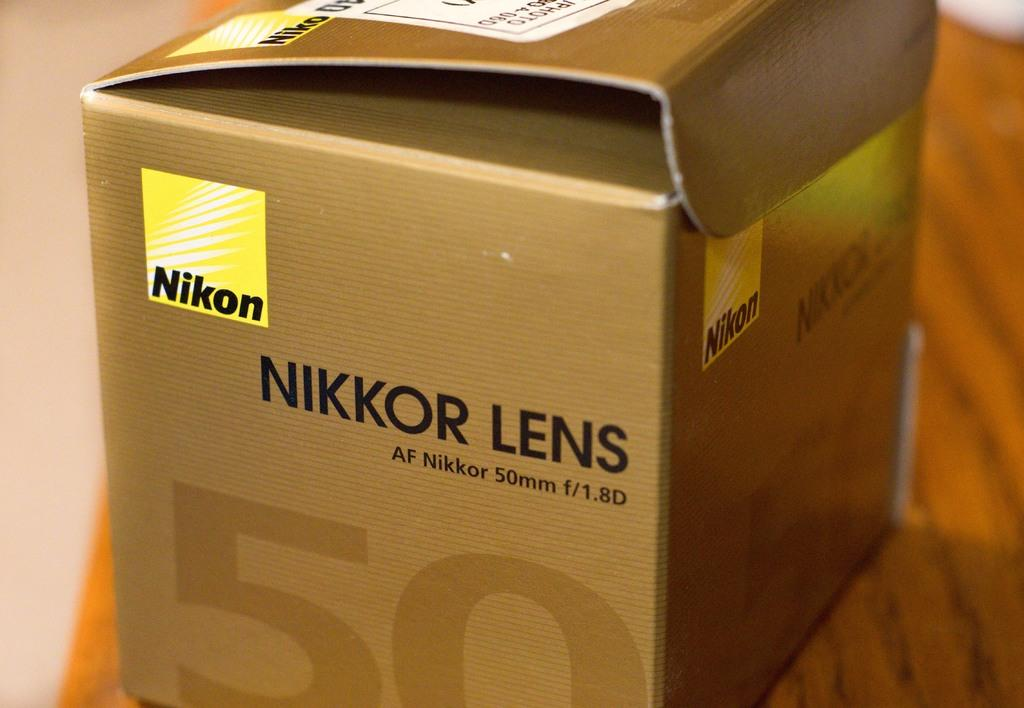<image>
Offer a succinct explanation of the picture presented. A cardboard box from a Nikkor lens sits on a wooden table. 